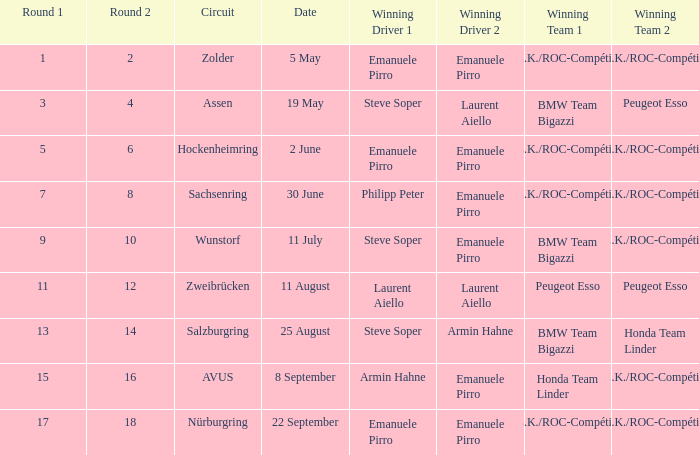In which round on june 30 does the a.z.k./roc-compétition team win? 7 8. 